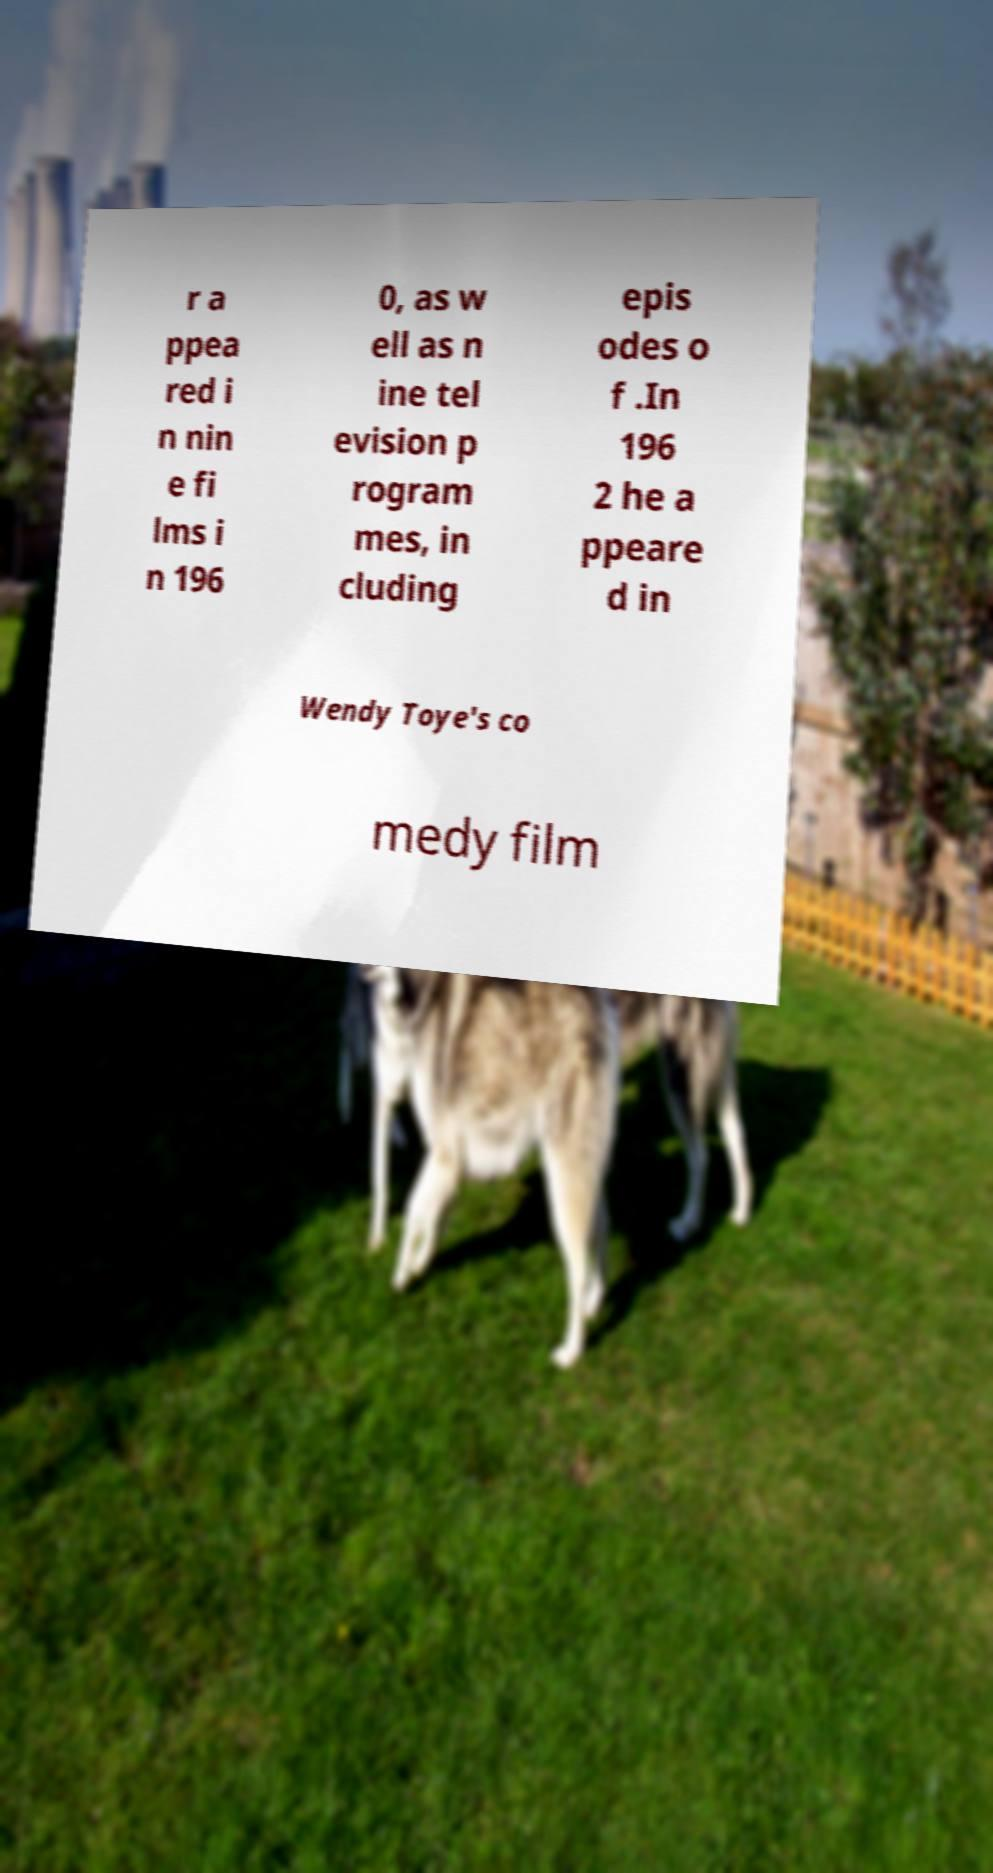For documentation purposes, I need the text within this image transcribed. Could you provide that? r a ppea red i n nin e fi lms i n 196 0, as w ell as n ine tel evision p rogram mes, in cluding epis odes o f .In 196 2 he a ppeare d in Wendy Toye's co medy film 